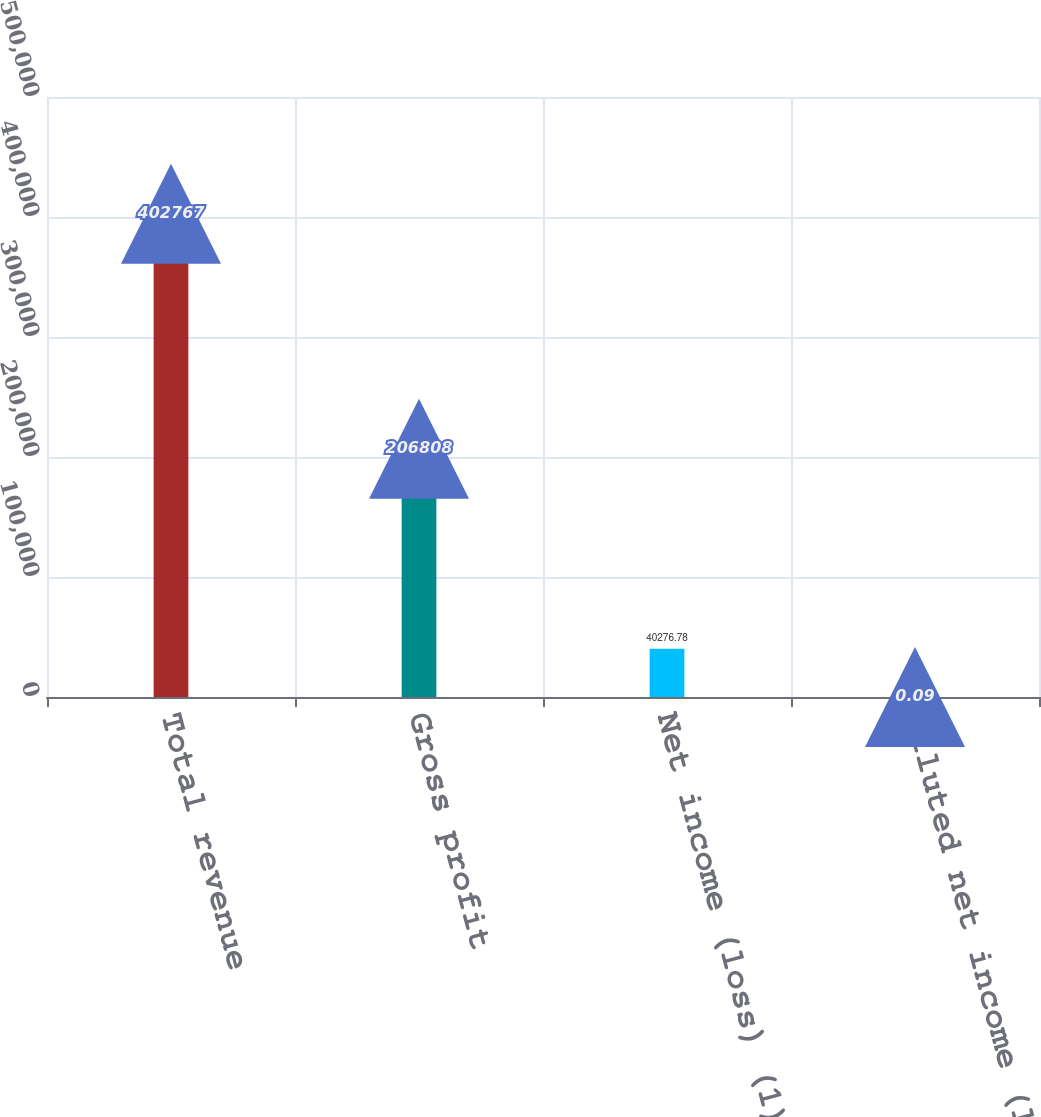Convert chart to OTSL. <chart><loc_0><loc_0><loc_500><loc_500><bar_chart><fcel>Total revenue<fcel>Gross profit<fcel>Net income (loss) (1)<fcel>Diluted net income (loss) per<nl><fcel>402767<fcel>206808<fcel>40276.8<fcel>0.09<nl></chart> 